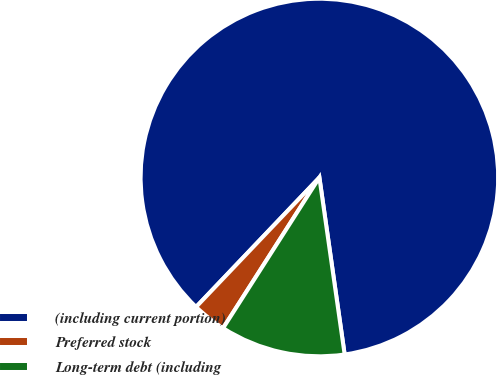Convert chart to OTSL. <chart><loc_0><loc_0><loc_500><loc_500><pie_chart><fcel>(including current portion)<fcel>Preferred stock<fcel>Long-term debt (including<nl><fcel>85.63%<fcel>3.06%<fcel>11.31%<nl></chart> 